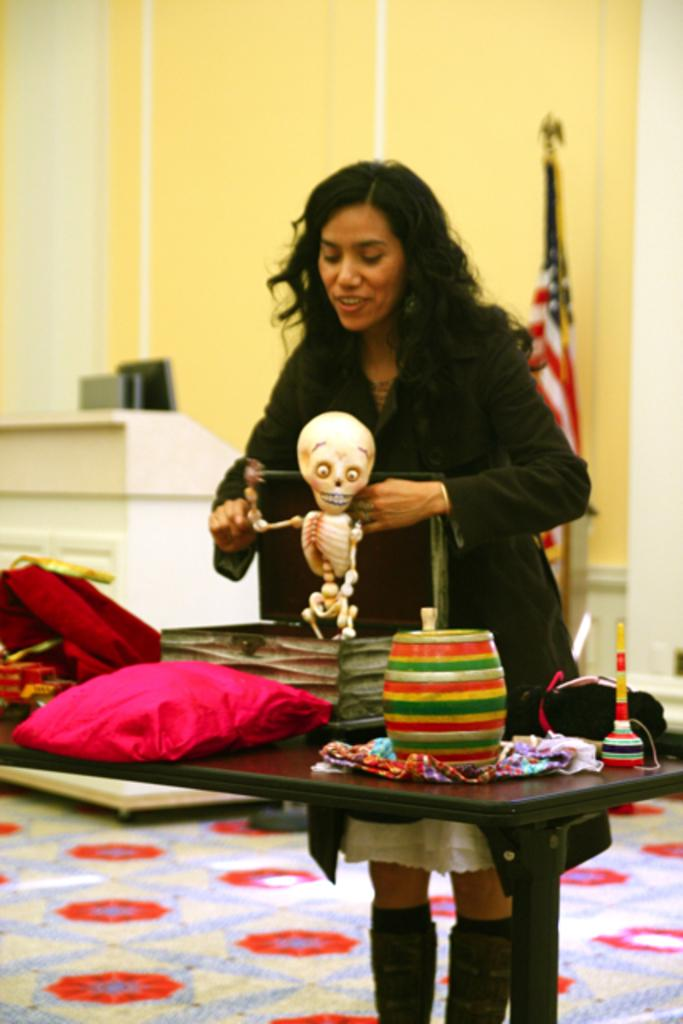What is the main subject in the image? There is a woman standing in the image. What is located near the woman in the image? There is a table in the image. What is on top of the table in the image? There is cloth on the table, and there are other objects on the table. What can be seen in the background of the image? There is a flag and a wall in the background of the image. What request is the woman making in the image? There is no indication in the image that the woman is making any request. 